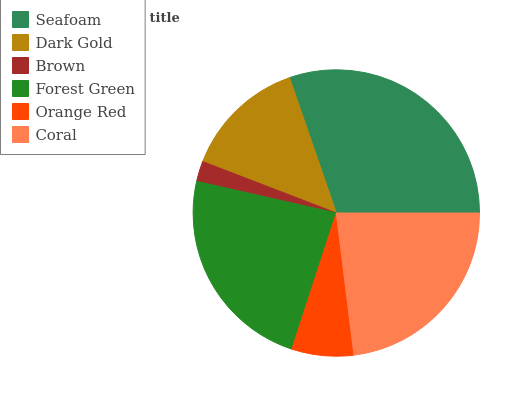Is Brown the minimum?
Answer yes or no. Yes. Is Seafoam the maximum?
Answer yes or no. Yes. Is Dark Gold the minimum?
Answer yes or no. No. Is Dark Gold the maximum?
Answer yes or no. No. Is Seafoam greater than Dark Gold?
Answer yes or no. Yes. Is Dark Gold less than Seafoam?
Answer yes or no. Yes. Is Dark Gold greater than Seafoam?
Answer yes or no. No. Is Seafoam less than Dark Gold?
Answer yes or no. No. Is Coral the high median?
Answer yes or no. Yes. Is Dark Gold the low median?
Answer yes or no. Yes. Is Brown the high median?
Answer yes or no. No. Is Brown the low median?
Answer yes or no. No. 